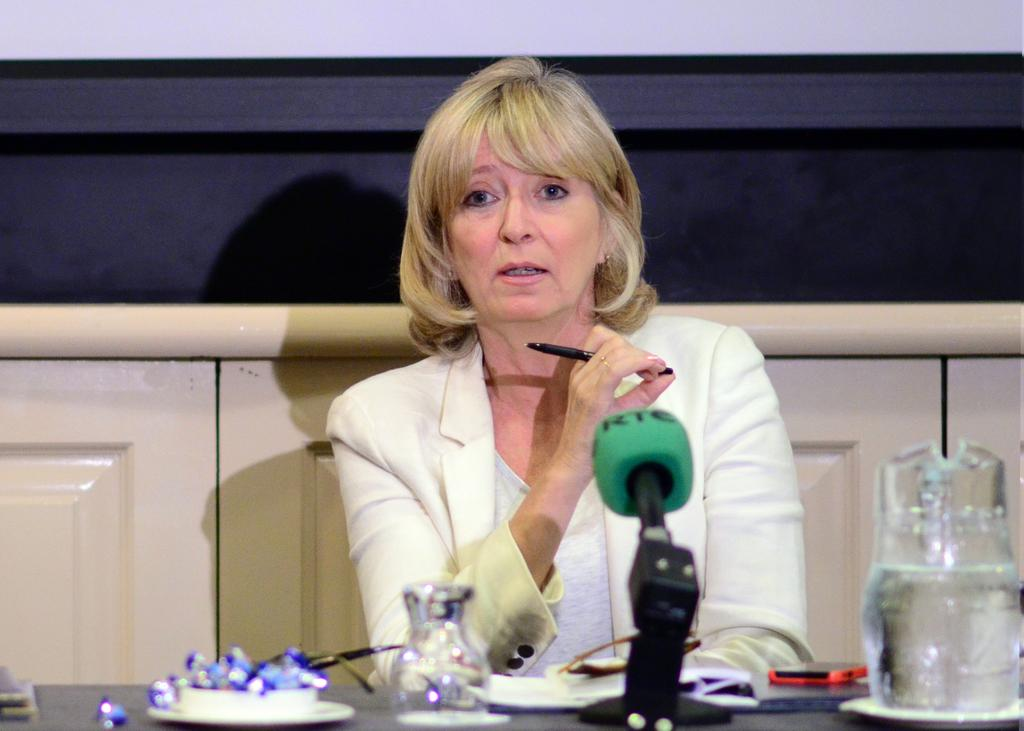Provide a one-sentence caption for the provided image. A woman in an interview speaks into an "RTC" brand microphone. 